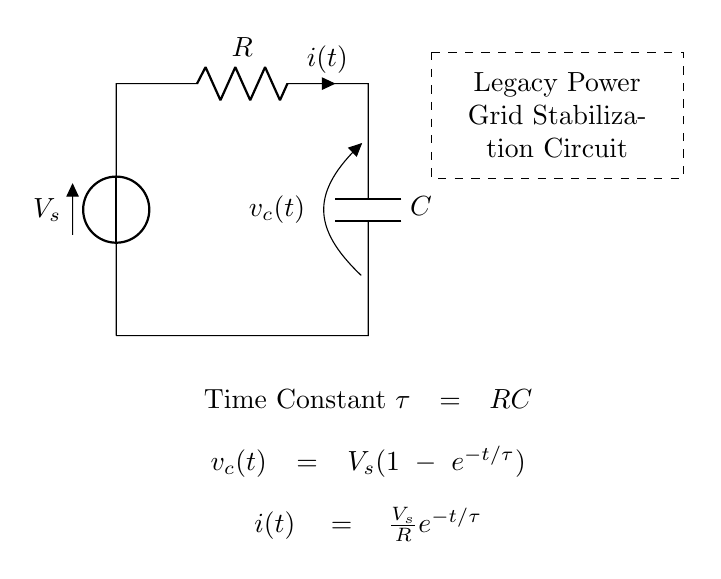What is the voltage source in this circuit? The voltage source is represented by the symbol V at the left side of the circuit. It is labeled as V_s, indicating it supplies voltage to the circuit.
Answer: V_s What component limits the current in this circuit? The current is limited by the resistor, which is represented by the symbol R in the circuit. It is positioned between the voltage source and the capacitor.
Answer: R What is the time constant for this RC circuit? The time constant is denoted by the symbol τ and is defined as the product of resistance (R) and capacitance (C) in the circuit. This means τ = RC based on the information provided in the diagram.
Answer: RC What is the expression for the voltage across the capacitor? The expression for the voltage across the capacitor is written as v_c(t) = V_s(1-e^{-t/τ}), indicating how the voltage changes over time as the capacitor charges.
Answer: V_s(1-e^{-t/τ}) How does the current behave over time in this circuit? The current is expressed as i(t) = V_s/R * e^{-t/τ}, showing that the current decreases exponentially over time as the capacitor charges, starting from its maximum value when the capacitor is uncharged.
Answer: V_s/R * e^{-t/τ} What does the dashed rectangle represent in this circuit? The dashed rectangle signifies a section of the circuit design, specifically marking the area of the "Legacy Power Grid Stabilization Circuit" indicated by the surrounding text.
Answer: Legacy Power Grid Stabilization Circuit 